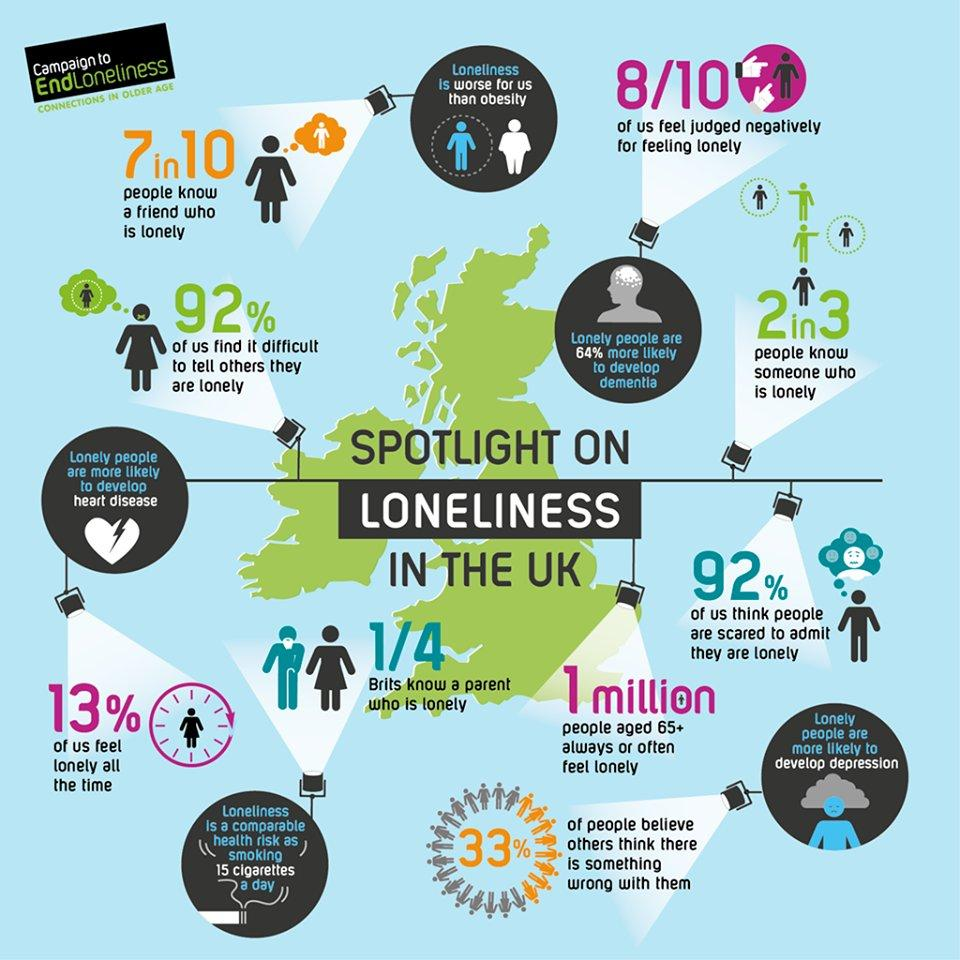Identify some key points in this picture. According to a recent survey, only 8% of people find it easy to tell others that they are lonely. Loneliness has been linked to the development of several health adversities, including depression, dementia, and heart diseases. Obesity is considered to be better than loneliness. A recent study found that 64% of people who are lonely are at a higher risk of developing dementia. According to a study, approximately 80% of people are afraid of being judged negatively because of loneliness. 